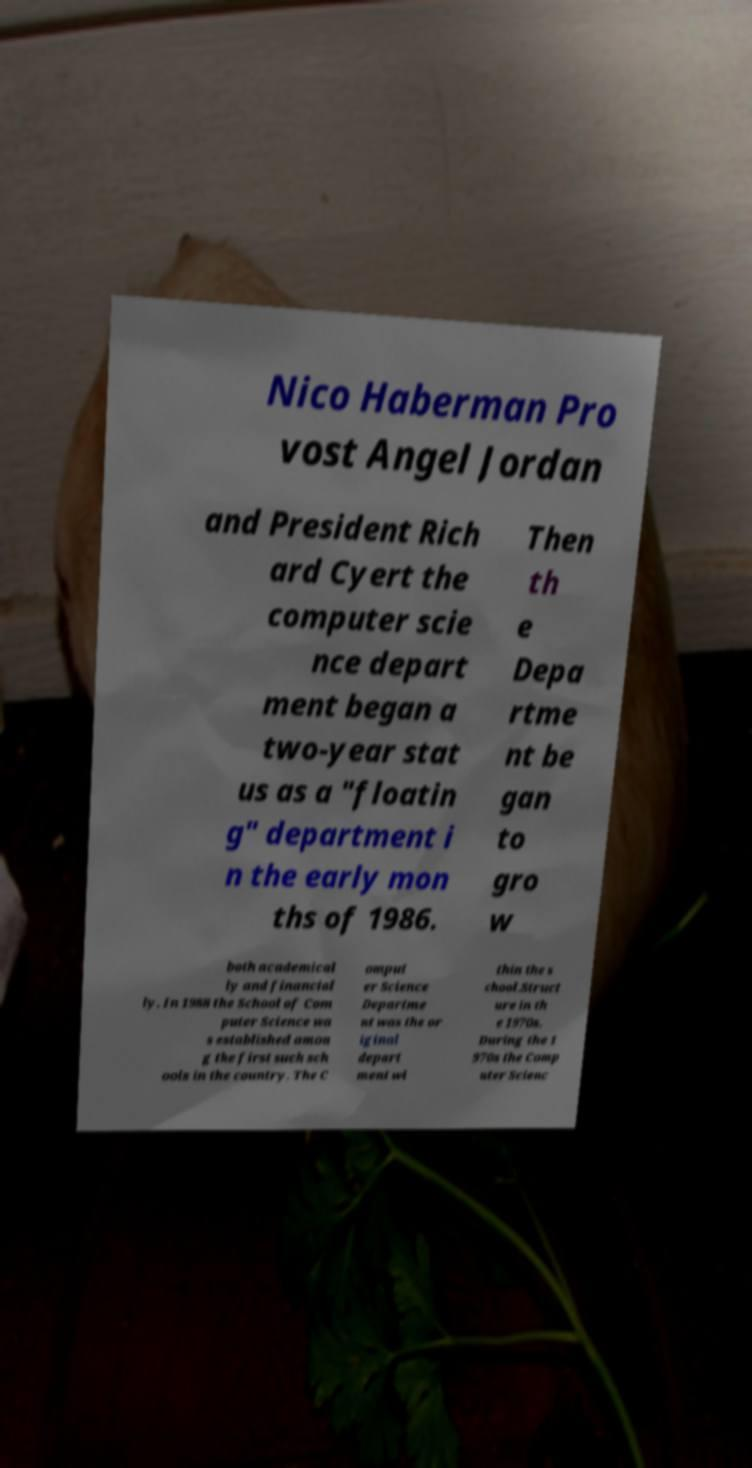There's text embedded in this image that I need extracted. Can you transcribe it verbatim? Nico Haberman Pro vost Angel Jordan and President Rich ard Cyert the computer scie nce depart ment began a two-year stat us as a "floatin g" department i n the early mon ths of 1986. Then th e Depa rtme nt be gan to gro w both academical ly and financial ly. In 1988 the School of Com puter Science wa s established amon g the first such sch ools in the country. The C omput er Science Departme nt was the or iginal depart ment wi thin the s chool.Struct ure in th e 1970s. During the 1 970s the Comp uter Scienc 